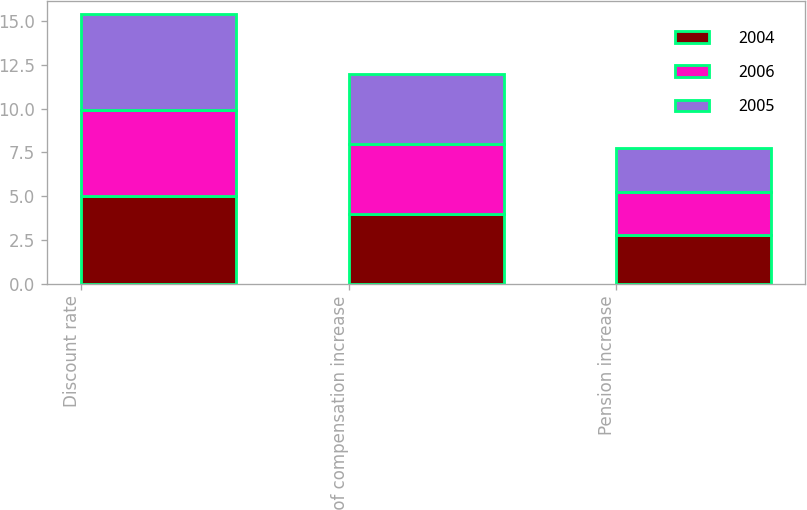Convert chart. <chart><loc_0><loc_0><loc_500><loc_500><stacked_bar_chart><ecel><fcel>Discount rate<fcel>Rate of compensation increase<fcel>Pension increase<nl><fcel>2004<fcel>5<fcel>4<fcel>2.75<nl><fcel>2006<fcel>4.9<fcel>4<fcel>2.5<nl><fcel>2005<fcel>5.5<fcel>4<fcel>2.5<nl></chart> 